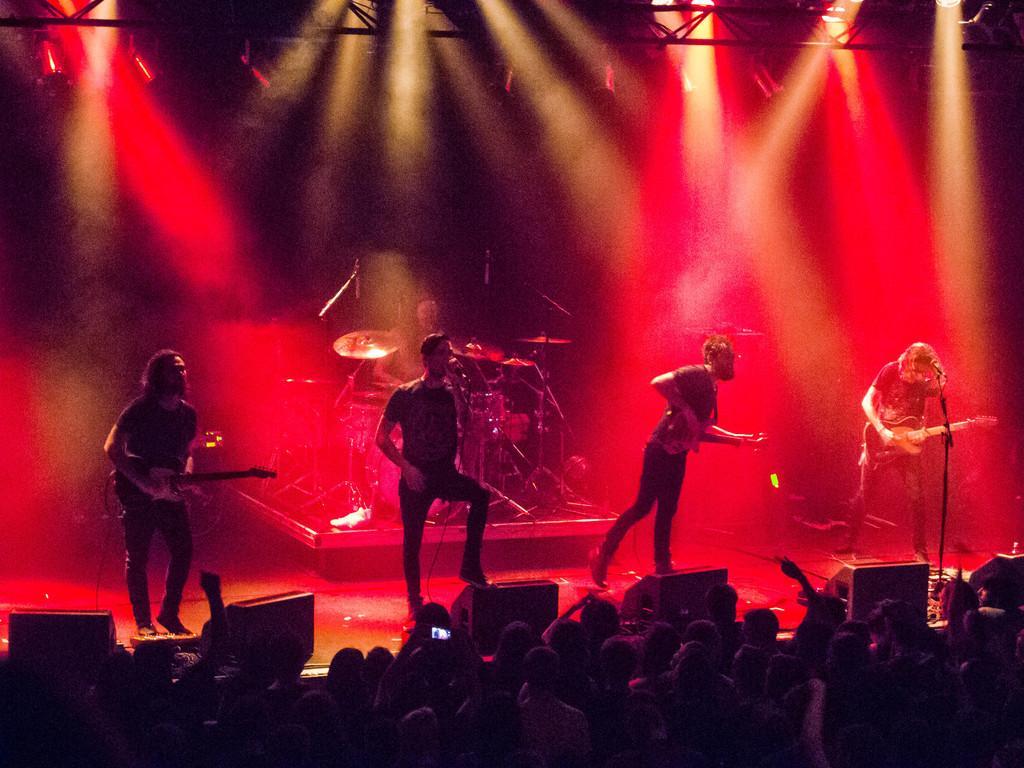How would you summarize this image in a sentence or two? Front there are audience. On this stage these two persons are playing guitar and in middle of this person's a person is standing and singing in-front of mic. On the left side of the image there is a focusing light. On the right side of the image a person is playing guitar and holding mic. Backside of this person's another person is playing musical instruments. 